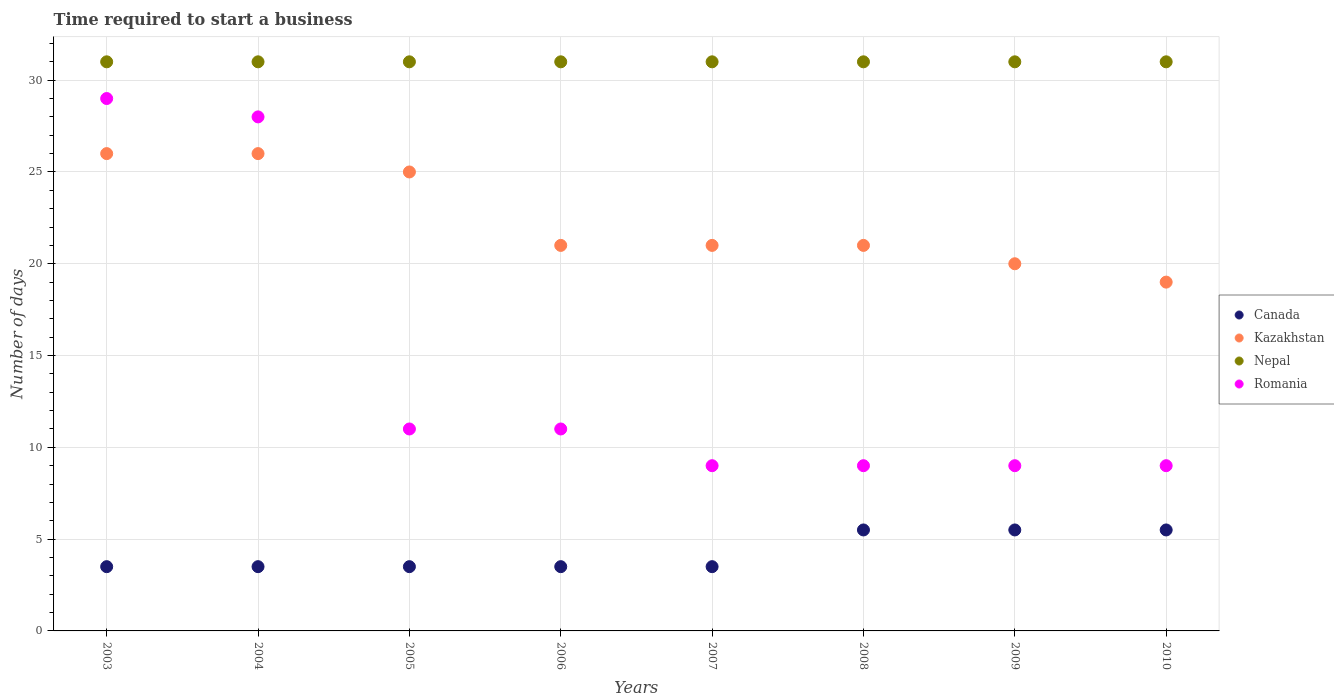Is the number of dotlines equal to the number of legend labels?
Make the answer very short. Yes. What is the number of days required to start a business in Kazakhstan in 2009?
Offer a terse response. 20. What is the total number of days required to start a business in Romania in the graph?
Keep it short and to the point. 115. What is the difference between the number of days required to start a business in Kazakhstan in 2003 and the number of days required to start a business in Romania in 2010?
Provide a short and direct response. 17. What is the average number of days required to start a business in Romania per year?
Your response must be concise. 14.38. What is the ratio of the number of days required to start a business in Kazakhstan in 2005 to that in 2008?
Your response must be concise. 1.19. What is the difference between the highest and the lowest number of days required to start a business in Kazakhstan?
Provide a short and direct response. 7. In how many years, is the number of days required to start a business in Kazakhstan greater than the average number of days required to start a business in Kazakhstan taken over all years?
Keep it short and to the point. 3. Is the sum of the number of days required to start a business in Nepal in 2003 and 2006 greater than the maximum number of days required to start a business in Kazakhstan across all years?
Ensure brevity in your answer.  Yes. Is the number of days required to start a business in Romania strictly greater than the number of days required to start a business in Kazakhstan over the years?
Keep it short and to the point. No. How many dotlines are there?
Your answer should be compact. 4. How many years are there in the graph?
Offer a very short reply. 8. Are the values on the major ticks of Y-axis written in scientific E-notation?
Provide a succinct answer. No. Does the graph contain any zero values?
Provide a short and direct response. No. Where does the legend appear in the graph?
Your answer should be compact. Center right. What is the title of the graph?
Give a very brief answer. Time required to start a business. What is the label or title of the X-axis?
Make the answer very short. Years. What is the label or title of the Y-axis?
Provide a succinct answer. Number of days. What is the Number of days in Kazakhstan in 2003?
Your answer should be compact. 26. What is the Number of days of Canada in 2004?
Offer a terse response. 3.5. What is the Number of days of Nepal in 2004?
Provide a succinct answer. 31. What is the Number of days in Canada in 2005?
Offer a very short reply. 3.5. What is the Number of days in Nepal in 2005?
Your answer should be very brief. 31. What is the Number of days in Romania in 2006?
Offer a very short reply. 11. What is the Number of days in Kazakhstan in 2007?
Your response must be concise. 21. What is the Number of days in Nepal in 2007?
Give a very brief answer. 31. What is the Number of days of Canada in 2008?
Your response must be concise. 5.5. What is the Number of days in Nepal in 2008?
Offer a very short reply. 31. What is the Number of days in Kazakhstan in 2009?
Provide a succinct answer. 20. What is the Number of days of Canada in 2010?
Ensure brevity in your answer.  5.5. What is the Number of days in Romania in 2010?
Offer a terse response. 9. Across all years, what is the maximum Number of days in Canada?
Offer a very short reply. 5.5. Across all years, what is the minimum Number of days of Canada?
Offer a terse response. 3.5. Across all years, what is the minimum Number of days in Romania?
Your answer should be compact. 9. What is the total Number of days of Kazakhstan in the graph?
Offer a terse response. 179. What is the total Number of days of Nepal in the graph?
Provide a succinct answer. 248. What is the total Number of days in Romania in the graph?
Your answer should be very brief. 115. What is the difference between the Number of days of Canada in 2003 and that in 2004?
Offer a terse response. 0. What is the difference between the Number of days in Kazakhstan in 2003 and that in 2004?
Keep it short and to the point. 0. What is the difference between the Number of days of Romania in 2003 and that in 2004?
Give a very brief answer. 1. What is the difference between the Number of days of Canada in 2003 and that in 2005?
Offer a terse response. 0. What is the difference between the Number of days in Canada in 2003 and that in 2006?
Your answer should be very brief. 0. What is the difference between the Number of days in Kazakhstan in 2003 and that in 2006?
Offer a terse response. 5. What is the difference between the Number of days of Romania in 2003 and that in 2006?
Keep it short and to the point. 18. What is the difference between the Number of days of Canada in 2003 and that in 2007?
Keep it short and to the point. 0. What is the difference between the Number of days in Kazakhstan in 2003 and that in 2007?
Provide a short and direct response. 5. What is the difference between the Number of days of Nepal in 2003 and that in 2007?
Keep it short and to the point. 0. What is the difference between the Number of days in Romania in 2003 and that in 2007?
Your answer should be very brief. 20. What is the difference between the Number of days of Canada in 2003 and that in 2008?
Your answer should be compact. -2. What is the difference between the Number of days in Nepal in 2003 and that in 2008?
Your answer should be compact. 0. What is the difference between the Number of days in Romania in 2003 and that in 2008?
Your answer should be very brief. 20. What is the difference between the Number of days of Canada in 2003 and that in 2009?
Offer a terse response. -2. What is the difference between the Number of days in Romania in 2003 and that in 2009?
Make the answer very short. 20. What is the difference between the Number of days of Canada in 2003 and that in 2010?
Your answer should be very brief. -2. What is the difference between the Number of days in Canada in 2004 and that in 2005?
Provide a succinct answer. 0. What is the difference between the Number of days in Kazakhstan in 2004 and that in 2005?
Offer a very short reply. 1. What is the difference between the Number of days of Nepal in 2004 and that in 2005?
Give a very brief answer. 0. What is the difference between the Number of days of Romania in 2004 and that in 2005?
Your response must be concise. 17. What is the difference between the Number of days of Romania in 2004 and that in 2006?
Keep it short and to the point. 17. What is the difference between the Number of days of Canada in 2004 and that in 2007?
Provide a succinct answer. 0. What is the difference between the Number of days of Kazakhstan in 2004 and that in 2007?
Your answer should be very brief. 5. What is the difference between the Number of days in Canada in 2004 and that in 2008?
Offer a very short reply. -2. What is the difference between the Number of days of Romania in 2004 and that in 2008?
Your response must be concise. 19. What is the difference between the Number of days in Canada in 2004 and that in 2009?
Offer a very short reply. -2. What is the difference between the Number of days in Nepal in 2004 and that in 2009?
Offer a very short reply. 0. What is the difference between the Number of days in Kazakhstan in 2004 and that in 2010?
Your response must be concise. 7. What is the difference between the Number of days in Canada in 2005 and that in 2006?
Keep it short and to the point. 0. What is the difference between the Number of days of Kazakhstan in 2005 and that in 2006?
Make the answer very short. 4. What is the difference between the Number of days in Nepal in 2005 and that in 2007?
Provide a short and direct response. 0. What is the difference between the Number of days in Nepal in 2005 and that in 2008?
Make the answer very short. 0. What is the difference between the Number of days of Romania in 2005 and that in 2008?
Your response must be concise. 2. What is the difference between the Number of days in Canada in 2005 and that in 2009?
Your response must be concise. -2. What is the difference between the Number of days of Nepal in 2005 and that in 2009?
Ensure brevity in your answer.  0. What is the difference between the Number of days of Romania in 2005 and that in 2009?
Provide a succinct answer. 2. What is the difference between the Number of days in Kazakhstan in 2006 and that in 2007?
Offer a terse response. 0. What is the difference between the Number of days of Romania in 2006 and that in 2007?
Give a very brief answer. 2. What is the difference between the Number of days in Canada in 2006 and that in 2008?
Your answer should be very brief. -2. What is the difference between the Number of days in Nepal in 2006 and that in 2008?
Provide a succinct answer. 0. What is the difference between the Number of days in Romania in 2006 and that in 2008?
Offer a terse response. 2. What is the difference between the Number of days in Canada in 2006 and that in 2009?
Your answer should be very brief. -2. What is the difference between the Number of days in Kazakhstan in 2006 and that in 2009?
Keep it short and to the point. 1. What is the difference between the Number of days in Nepal in 2006 and that in 2009?
Provide a short and direct response. 0. What is the difference between the Number of days in Canada in 2006 and that in 2010?
Keep it short and to the point. -2. What is the difference between the Number of days in Nepal in 2006 and that in 2010?
Ensure brevity in your answer.  0. What is the difference between the Number of days of Romania in 2006 and that in 2010?
Offer a very short reply. 2. What is the difference between the Number of days in Kazakhstan in 2007 and that in 2008?
Ensure brevity in your answer.  0. What is the difference between the Number of days in Nepal in 2007 and that in 2008?
Ensure brevity in your answer.  0. What is the difference between the Number of days of Kazakhstan in 2007 and that in 2009?
Offer a very short reply. 1. What is the difference between the Number of days of Nepal in 2007 and that in 2010?
Make the answer very short. 0. What is the difference between the Number of days in Kazakhstan in 2008 and that in 2009?
Your response must be concise. 1. What is the difference between the Number of days in Canada in 2008 and that in 2010?
Offer a very short reply. 0. What is the difference between the Number of days in Kazakhstan in 2008 and that in 2010?
Offer a very short reply. 2. What is the difference between the Number of days of Nepal in 2008 and that in 2010?
Make the answer very short. 0. What is the difference between the Number of days in Romania in 2008 and that in 2010?
Make the answer very short. 0. What is the difference between the Number of days in Nepal in 2009 and that in 2010?
Provide a succinct answer. 0. What is the difference between the Number of days of Canada in 2003 and the Number of days of Kazakhstan in 2004?
Give a very brief answer. -22.5. What is the difference between the Number of days in Canada in 2003 and the Number of days in Nepal in 2004?
Offer a terse response. -27.5. What is the difference between the Number of days in Canada in 2003 and the Number of days in Romania in 2004?
Offer a very short reply. -24.5. What is the difference between the Number of days in Kazakhstan in 2003 and the Number of days in Nepal in 2004?
Keep it short and to the point. -5. What is the difference between the Number of days of Nepal in 2003 and the Number of days of Romania in 2004?
Ensure brevity in your answer.  3. What is the difference between the Number of days in Canada in 2003 and the Number of days in Kazakhstan in 2005?
Ensure brevity in your answer.  -21.5. What is the difference between the Number of days in Canada in 2003 and the Number of days in Nepal in 2005?
Make the answer very short. -27.5. What is the difference between the Number of days of Nepal in 2003 and the Number of days of Romania in 2005?
Give a very brief answer. 20. What is the difference between the Number of days of Canada in 2003 and the Number of days of Kazakhstan in 2006?
Your answer should be very brief. -17.5. What is the difference between the Number of days of Canada in 2003 and the Number of days of Nepal in 2006?
Give a very brief answer. -27.5. What is the difference between the Number of days of Kazakhstan in 2003 and the Number of days of Romania in 2006?
Make the answer very short. 15. What is the difference between the Number of days of Nepal in 2003 and the Number of days of Romania in 2006?
Offer a very short reply. 20. What is the difference between the Number of days in Canada in 2003 and the Number of days in Kazakhstan in 2007?
Ensure brevity in your answer.  -17.5. What is the difference between the Number of days in Canada in 2003 and the Number of days in Nepal in 2007?
Provide a succinct answer. -27.5. What is the difference between the Number of days in Canada in 2003 and the Number of days in Romania in 2007?
Provide a short and direct response. -5.5. What is the difference between the Number of days of Canada in 2003 and the Number of days of Kazakhstan in 2008?
Keep it short and to the point. -17.5. What is the difference between the Number of days in Canada in 2003 and the Number of days in Nepal in 2008?
Your answer should be compact. -27.5. What is the difference between the Number of days in Kazakhstan in 2003 and the Number of days in Nepal in 2008?
Keep it short and to the point. -5. What is the difference between the Number of days in Nepal in 2003 and the Number of days in Romania in 2008?
Provide a short and direct response. 22. What is the difference between the Number of days of Canada in 2003 and the Number of days of Kazakhstan in 2009?
Provide a short and direct response. -16.5. What is the difference between the Number of days in Canada in 2003 and the Number of days in Nepal in 2009?
Ensure brevity in your answer.  -27.5. What is the difference between the Number of days in Kazakhstan in 2003 and the Number of days in Romania in 2009?
Provide a short and direct response. 17. What is the difference between the Number of days of Nepal in 2003 and the Number of days of Romania in 2009?
Your answer should be very brief. 22. What is the difference between the Number of days in Canada in 2003 and the Number of days in Kazakhstan in 2010?
Give a very brief answer. -15.5. What is the difference between the Number of days of Canada in 2003 and the Number of days of Nepal in 2010?
Provide a succinct answer. -27.5. What is the difference between the Number of days of Canada in 2003 and the Number of days of Romania in 2010?
Your response must be concise. -5.5. What is the difference between the Number of days in Kazakhstan in 2003 and the Number of days in Romania in 2010?
Your answer should be compact. 17. What is the difference between the Number of days of Canada in 2004 and the Number of days of Kazakhstan in 2005?
Ensure brevity in your answer.  -21.5. What is the difference between the Number of days of Canada in 2004 and the Number of days of Nepal in 2005?
Your answer should be very brief. -27.5. What is the difference between the Number of days in Canada in 2004 and the Number of days in Romania in 2005?
Your answer should be compact. -7.5. What is the difference between the Number of days in Nepal in 2004 and the Number of days in Romania in 2005?
Provide a short and direct response. 20. What is the difference between the Number of days in Canada in 2004 and the Number of days in Kazakhstan in 2006?
Your answer should be very brief. -17.5. What is the difference between the Number of days in Canada in 2004 and the Number of days in Nepal in 2006?
Offer a terse response. -27.5. What is the difference between the Number of days of Canada in 2004 and the Number of days of Romania in 2006?
Provide a succinct answer. -7.5. What is the difference between the Number of days of Kazakhstan in 2004 and the Number of days of Nepal in 2006?
Provide a short and direct response. -5. What is the difference between the Number of days of Kazakhstan in 2004 and the Number of days of Romania in 2006?
Give a very brief answer. 15. What is the difference between the Number of days of Nepal in 2004 and the Number of days of Romania in 2006?
Keep it short and to the point. 20. What is the difference between the Number of days of Canada in 2004 and the Number of days of Kazakhstan in 2007?
Offer a very short reply. -17.5. What is the difference between the Number of days in Canada in 2004 and the Number of days in Nepal in 2007?
Ensure brevity in your answer.  -27.5. What is the difference between the Number of days of Canada in 2004 and the Number of days of Romania in 2007?
Offer a terse response. -5.5. What is the difference between the Number of days of Kazakhstan in 2004 and the Number of days of Romania in 2007?
Provide a short and direct response. 17. What is the difference between the Number of days in Canada in 2004 and the Number of days in Kazakhstan in 2008?
Your answer should be compact. -17.5. What is the difference between the Number of days of Canada in 2004 and the Number of days of Nepal in 2008?
Your answer should be very brief. -27.5. What is the difference between the Number of days of Kazakhstan in 2004 and the Number of days of Nepal in 2008?
Your response must be concise. -5. What is the difference between the Number of days of Kazakhstan in 2004 and the Number of days of Romania in 2008?
Ensure brevity in your answer.  17. What is the difference between the Number of days in Nepal in 2004 and the Number of days in Romania in 2008?
Your answer should be very brief. 22. What is the difference between the Number of days of Canada in 2004 and the Number of days of Kazakhstan in 2009?
Provide a short and direct response. -16.5. What is the difference between the Number of days in Canada in 2004 and the Number of days in Nepal in 2009?
Offer a very short reply. -27.5. What is the difference between the Number of days in Kazakhstan in 2004 and the Number of days in Nepal in 2009?
Make the answer very short. -5. What is the difference between the Number of days in Canada in 2004 and the Number of days in Kazakhstan in 2010?
Make the answer very short. -15.5. What is the difference between the Number of days of Canada in 2004 and the Number of days of Nepal in 2010?
Keep it short and to the point. -27.5. What is the difference between the Number of days of Canada in 2004 and the Number of days of Romania in 2010?
Ensure brevity in your answer.  -5.5. What is the difference between the Number of days of Kazakhstan in 2004 and the Number of days of Nepal in 2010?
Ensure brevity in your answer.  -5. What is the difference between the Number of days in Nepal in 2004 and the Number of days in Romania in 2010?
Make the answer very short. 22. What is the difference between the Number of days in Canada in 2005 and the Number of days in Kazakhstan in 2006?
Your answer should be very brief. -17.5. What is the difference between the Number of days of Canada in 2005 and the Number of days of Nepal in 2006?
Give a very brief answer. -27.5. What is the difference between the Number of days of Canada in 2005 and the Number of days of Romania in 2006?
Ensure brevity in your answer.  -7.5. What is the difference between the Number of days in Nepal in 2005 and the Number of days in Romania in 2006?
Provide a succinct answer. 20. What is the difference between the Number of days in Canada in 2005 and the Number of days in Kazakhstan in 2007?
Make the answer very short. -17.5. What is the difference between the Number of days in Canada in 2005 and the Number of days in Nepal in 2007?
Your answer should be very brief. -27.5. What is the difference between the Number of days in Canada in 2005 and the Number of days in Romania in 2007?
Offer a very short reply. -5.5. What is the difference between the Number of days of Nepal in 2005 and the Number of days of Romania in 2007?
Provide a succinct answer. 22. What is the difference between the Number of days in Canada in 2005 and the Number of days in Kazakhstan in 2008?
Keep it short and to the point. -17.5. What is the difference between the Number of days of Canada in 2005 and the Number of days of Nepal in 2008?
Provide a succinct answer. -27.5. What is the difference between the Number of days of Canada in 2005 and the Number of days of Romania in 2008?
Offer a very short reply. -5.5. What is the difference between the Number of days in Nepal in 2005 and the Number of days in Romania in 2008?
Your answer should be compact. 22. What is the difference between the Number of days of Canada in 2005 and the Number of days of Kazakhstan in 2009?
Give a very brief answer. -16.5. What is the difference between the Number of days in Canada in 2005 and the Number of days in Nepal in 2009?
Your answer should be very brief. -27.5. What is the difference between the Number of days in Canada in 2005 and the Number of days in Romania in 2009?
Provide a short and direct response. -5.5. What is the difference between the Number of days of Kazakhstan in 2005 and the Number of days of Romania in 2009?
Make the answer very short. 16. What is the difference between the Number of days of Nepal in 2005 and the Number of days of Romania in 2009?
Ensure brevity in your answer.  22. What is the difference between the Number of days in Canada in 2005 and the Number of days in Kazakhstan in 2010?
Give a very brief answer. -15.5. What is the difference between the Number of days of Canada in 2005 and the Number of days of Nepal in 2010?
Ensure brevity in your answer.  -27.5. What is the difference between the Number of days in Nepal in 2005 and the Number of days in Romania in 2010?
Keep it short and to the point. 22. What is the difference between the Number of days of Canada in 2006 and the Number of days of Kazakhstan in 2007?
Give a very brief answer. -17.5. What is the difference between the Number of days in Canada in 2006 and the Number of days in Nepal in 2007?
Give a very brief answer. -27.5. What is the difference between the Number of days in Kazakhstan in 2006 and the Number of days in Nepal in 2007?
Offer a terse response. -10. What is the difference between the Number of days of Kazakhstan in 2006 and the Number of days of Romania in 2007?
Offer a very short reply. 12. What is the difference between the Number of days of Nepal in 2006 and the Number of days of Romania in 2007?
Keep it short and to the point. 22. What is the difference between the Number of days of Canada in 2006 and the Number of days of Kazakhstan in 2008?
Your answer should be compact. -17.5. What is the difference between the Number of days of Canada in 2006 and the Number of days of Nepal in 2008?
Make the answer very short. -27.5. What is the difference between the Number of days in Canada in 2006 and the Number of days in Romania in 2008?
Keep it short and to the point. -5.5. What is the difference between the Number of days of Nepal in 2006 and the Number of days of Romania in 2008?
Make the answer very short. 22. What is the difference between the Number of days in Canada in 2006 and the Number of days in Kazakhstan in 2009?
Give a very brief answer. -16.5. What is the difference between the Number of days of Canada in 2006 and the Number of days of Nepal in 2009?
Your response must be concise. -27.5. What is the difference between the Number of days of Kazakhstan in 2006 and the Number of days of Romania in 2009?
Keep it short and to the point. 12. What is the difference between the Number of days in Canada in 2006 and the Number of days in Kazakhstan in 2010?
Keep it short and to the point. -15.5. What is the difference between the Number of days in Canada in 2006 and the Number of days in Nepal in 2010?
Offer a very short reply. -27.5. What is the difference between the Number of days of Canada in 2007 and the Number of days of Kazakhstan in 2008?
Offer a terse response. -17.5. What is the difference between the Number of days of Canada in 2007 and the Number of days of Nepal in 2008?
Your answer should be compact. -27.5. What is the difference between the Number of days in Canada in 2007 and the Number of days in Romania in 2008?
Give a very brief answer. -5.5. What is the difference between the Number of days in Kazakhstan in 2007 and the Number of days in Nepal in 2008?
Ensure brevity in your answer.  -10. What is the difference between the Number of days of Canada in 2007 and the Number of days of Kazakhstan in 2009?
Make the answer very short. -16.5. What is the difference between the Number of days of Canada in 2007 and the Number of days of Nepal in 2009?
Ensure brevity in your answer.  -27.5. What is the difference between the Number of days of Canada in 2007 and the Number of days of Romania in 2009?
Your response must be concise. -5.5. What is the difference between the Number of days in Kazakhstan in 2007 and the Number of days in Nepal in 2009?
Provide a short and direct response. -10. What is the difference between the Number of days of Nepal in 2007 and the Number of days of Romania in 2009?
Your answer should be compact. 22. What is the difference between the Number of days of Canada in 2007 and the Number of days of Kazakhstan in 2010?
Offer a very short reply. -15.5. What is the difference between the Number of days in Canada in 2007 and the Number of days in Nepal in 2010?
Your answer should be very brief. -27.5. What is the difference between the Number of days in Kazakhstan in 2007 and the Number of days in Romania in 2010?
Keep it short and to the point. 12. What is the difference between the Number of days of Nepal in 2007 and the Number of days of Romania in 2010?
Your response must be concise. 22. What is the difference between the Number of days of Canada in 2008 and the Number of days of Nepal in 2009?
Give a very brief answer. -25.5. What is the difference between the Number of days in Canada in 2008 and the Number of days in Romania in 2009?
Give a very brief answer. -3.5. What is the difference between the Number of days of Kazakhstan in 2008 and the Number of days of Nepal in 2009?
Your response must be concise. -10. What is the difference between the Number of days of Kazakhstan in 2008 and the Number of days of Romania in 2009?
Keep it short and to the point. 12. What is the difference between the Number of days in Canada in 2008 and the Number of days in Nepal in 2010?
Ensure brevity in your answer.  -25.5. What is the difference between the Number of days of Canada in 2008 and the Number of days of Romania in 2010?
Give a very brief answer. -3.5. What is the difference between the Number of days of Nepal in 2008 and the Number of days of Romania in 2010?
Give a very brief answer. 22. What is the difference between the Number of days in Canada in 2009 and the Number of days in Kazakhstan in 2010?
Provide a short and direct response. -13.5. What is the difference between the Number of days in Canada in 2009 and the Number of days in Nepal in 2010?
Keep it short and to the point. -25.5. What is the difference between the Number of days of Kazakhstan in 2009 and the Number of days of Nepal in 2010?
Make the answer very short. -11. What is the difference between the Number of days in Nepal in 2009 and the Number of days in Romania in 2010?
Offer a very short reply. 22. What is the average Number of days of Canada per year?
Provide a succinct answer. 4.25. What is the average Number of days in Kazakhstan per year?
Your response must be concise. 22.38. What is the average Number of days in Romania per year?
Give a very brief answer. 14.38. In the year 2003, what is the difference between the Number of days in Canada and Number of days in Kazakhstan?
Your answer should be compact. -22.5. In the year 2003, what is the difference between the Number of days of Canada and Number of days of Nepal?
Give a very brief answer. -27.5. In the year 2003, what is the difference between the Number of days of Canada and Number of days of Romania?
Provide a short and direct response. -25.5. In the year 2004, what is the difference between the Number of days in Canada and Number of days in Kazakhstan?
Offer a terse response. -22.5. In the year 2004, what is the difference between the Number of days in Canada and Number of days in Nepal?
Provide a short and direct response. -27.5. In the year 2004, what is the difference between the Number of days in Canada and Number of days in Romania?
Provide a short and direct response. -24.5. In the year 2004, what is the difference between the Number of days in Nepal and Number of days in Romania?
Give a very brief answer. 3. In the year 2005, what is the difference between the Number of days in Canada and Number of days in Kazakhstan?
Your answer should be very brief. -21.5. In the year 2005, what is the difference between the Number of days in Canada and Number of days in Nepal?
Give a very brief answer. -27.5. In the year 2005, what is the difference between the Number of days of Canada and Number of days of Romania?
Provide a succinct answer. -7.5. In the year 2005, what is the difference between the Number of days in Kazakhstan and Number of days in Nepal?
Keep it short and to the point. -6. In the year 2005, what is the difference between the Number of days of Nepal and Number of days of Romania?
Ensure brevity in your answer.  20. In the year 2006, what is the difference between the Number of days in Canada and Number of days in Kazakhstan?
Ensure brevity in your answer.  -17.5. In the year 2006, what is the difference between the Number of days in Canada and Number of days in Nepal?
Ensure brevity in your answer.  -27.5. In the year 2006, what is the difference between the Number of days of Kazakhstan and Number of days of Nepal?
Offer a terse response. -10. In the year 2006, what is the difference between the Number of days of Kazakhstan and Number of days of Romania?
Provide a succinct answer. 10. In the year 2006, what is the difference between the Number of days in Nepal and Number of days in Romania?
Your answer should be very brief. 20. In the year 2007, what is the difference between the Number of days in Canada and Number of days in Kazakhstan?
Keep it short and to the point. -17.5. In the year 2007, what is the difference between the Number of days of Canada and Number of days of Nepal?
Keep it short and to the point. -27.5. In the year 2007, what is the difference between the Number of days in Canada and Number of days in Romania?
Keep it short and to the point. -5.5. In the year 2007, what is the difference between the Number of days in Kazakhstan and Number of days in Nepal?
Make the answer very short. -10. In the year 2007, what is the difference between the Number of days in Nepal and Number of days in Romania?
Your response must be concise. 22. In the year 2008, what is the difference between the Number of days in Canada and Number of days in Kazakhstan?
Ensure brevity in your answer.  -15.5. In the year 2008, what is the difference between the Number of days of Canada and Number of days of Nepal?
Keep it short and to the point. -25.5. In the year 2009, what is the difference between the Number of days in Canada and Number of days in Kazakhstan?
Ensure brevity in your answer.  -14.5. In the year 2009, what is the difference between the Number of days of Canada and Number of days of Nepal?
Offer a terse response. -25.5. In the year 2009, what is the difference between the Number of days in Canada and Number of days in Romania?
Your answer should be very brief. -3.5. In the year 2009, what is the difference between the Number of days of Kazakhstan and Number of days of Nepal?
Provide a succinct answer. -11. In the year 2009, what is the difference between the Number of days in Kazakhstan and Number of days in Romania?
Your response must be concise. 11. In the year 2009, what is the difference between the Number of days of Nepal and Number of days of Romania?
Your response must be concise. 22. In the year 2010, what is the difference between the Number of days of Canada and Number of days of Kazakhstan?
Your answer should be compact. -13.5. In the year 2010, what is the difference between the Number of days in Canada and Number of days in Nepal?
Keep it short and to the point. -25.5. In the year 2010, what is the difference between the Number of days of Canada and Number of days of Romania?
Keep it short and to the point. -3.5. In the year 2010, what is the difference between the Number of days in Kazakhstan and Number of days in Nepal?
Your answer should be compact. -12. In the year 2010, what is the difference between the Number of days in Kazakhstan and Number of days in Romania?
Give a very brief answer. 10. What is the ratio of the Number of days in Canada in 2003 to that in 2004?
Provide a succinct answer. 1. What is the ratio of the Number of days of Kazakhstan in 2003 to that in 2004?
Provide a succinct answer. 1. What is the ratio of the Number of days in Nepal in 2003 to that in 2004?
Provide a short and direct response. 1. What is the ratio of the Number of days in Romania in 2003 to that in 2004?
Offer a very short reply. 1.04. What is the ratio of the Number of days of Kazakhstan in 2003 to that in 2005?
Your response must be concise. 1.04. What is the ratio of the Number of days of Romania in 2003 to that in 2005?
Keep it short and to the point. 2.64. What is the ratio of the Number of days in Kazakhstan in 2003 to that in 2006?
Offer a very short reply. 1.24. What is the ratio of the Number of days in Romania in 2003 to that in 2006?
Your response must be concise. 2.64. What is the ratio of the Number of days in Canada in 2003 to that in 2007?
Give a very brief answer. 1. What is the ratio of the Number of days of Kazakhstan in 2003 to that in 2007?
Ensure brevity in your answer.  1.24. What is the ratio of the Number of days of Nepal in 2003 to that in 2007?
Your answer should be very brief. 1. What is the ratio of the Number of days in Romania in 2003 to that in 2007?
Ensure brevity in your answer.  3.22. What is the ratio of the Number of days of Canada in 2003 to that in 2008?
Keep it short and to the point. 0.64. What is the ratio of the Number of days of Kazakhstan in 2003 to that in 2008?
Your answer should be compact. 1.24. What is the ratio of the Number of days in Nepal in 2003 to that in 2008?
Your answer should be compact. 1. What is the ratio of the Number of days in Romania in 2003 to that in 2008?
Give a very brief answer. 3.22. What is the ratio of the Number of days in Canada in 2003 to that in 2009?
Ensure brevity in your answer.  0.64. What is the ratio of the Number of days of Nepal in 2003 to that in 2009?
Provide a short and direct response. 1. What is the ratio of the Number of days of Romania in 2003 to that in 2009?
Offer a terse response. 3.22. What is the ratio of the Number of days in Canada in 2003 to that in 2010?
Offer a terse response. 0.64. What is the ratio of the Number of days of Kazakhstan in 2003 to that in 2010?
Provide a succinct answer. 1.37. What is the ratio of the Number of days in Nepal in 2003 to that in 2010?
Your answer should be compact. 1. What is the ratio of the Number of days of Romania in 2003 to that in 2010?
Keep it short and to the point. 3.22. What is the ratio of the Number of days in Canada in 2004 to that in 2005?
Provide a short and direct response. 1. What is the ratio of the Number of days in Nepal in 2004 to that in 2005?
Your response must be concise. 1. What is the ratio of the Number of days in Romania in 2004 to that in 2005?
Keep it short and to the point. 2.55. What is the ratio of the Number of days of Canada in 2004 to that in 2006?
Your answer should be very brief. 1. What is the ratio of the Number of days of Kazakhstan in 2004 to that in 2006?
Your answer should be compact. 1.24. What is the ratio of the Number of days of Nepal in 2004 to that in 2006?
Your response must be concise. 1. What is the ratio of the Number of days of Romania in 2004 to that in 2006?
Provide a succinct answer. 2.55. What is the ratio of the Number of days of Kazakhstan in 2004 to that in 2007?
Provide a short and direct response. 1.24. What is the ratio of the Number of days in Romania in 2004 to that in 2007?
Provide a succinct answer. 3.11. What is the ratio of the Number of days in Canada in 2004 to that in 2008?
Provide a succinct answer. 0.64. What is the ratio of the Number of days of Kazakhstan in 2004 to that in 2008?
Your response must be concise. 1.24. What is the ratio of the Number of days in Nepal in 2004 to that in 2008?
Make the answer very short. 1. What is the ratio of the Number of days in Romania in 2004 to that in 2008?
Offer a very short reply. 3.11. What is the ratio of the Number of days of Canada in 2004 to that in 2009?
Provide a short and direct response. 0.64. What is the ratio of the Number of days of Romania in 2004 to that in 2009?
Provide a short and direct response. 3.11. What is the ratio of the Number of days of Canada in 2004 to that in 2010?
Offer a very short reply. 0.64. What is the ratio of the Number of days of Kazakhstan in 2004 to that in 2010?
Give a very brief answer. 1.37. What is the ratio of the Number of days in Nepal in 2004 to that in 2010?
Offer a very short reply. 1. What is the ratio of the Number of days in Romania in 2004 to that in 2010?
Your answer should be very brief. 3.11. What is the ratio of the Number of days in Kazakhstan in 2005 to that in 2006?
Provide a succinct answer. 1.19. What is the ratio of the Number of days in Nepal in 2005 to that in 2006?
Provide a short and direct response. 1. What is the ratio of the Number of days in Canada in 2005 to that in 2007?
Offer a terse response. 1. What is the ratio of the Number of days in Kazakhstan in 2005 to that in 2007?
Your answer should be very brief. 1.19. What is the ratio of the Number of days in Romania in 2005 to that in 2007?
Provide a succinct answer. 1.22. What is the ratio of the Number of days of Canada in 2005 to that in 2008?
Your answer should be compact. 0.64. What is the ratio of the Number of days of Kazakhstan in 2005 to that in 2008?
Give a very brief answer. 1.19. What is the ratio of the Number of days of Nepal in 2005 to that in 2008?
Give a very brief answer. 1. What is the ratio of the Number of days in Romania in 2005 to that in 2008?
Ensure brevity in your answer.  1.22. What is the ratio of the Number of days of Canada in 2005 to that in 2009?
Give a very brief answer. 0.64. What is the ratio of the Number of days of Nepal in 2005 to that in 2009?
Offer a very short reply. 1. What is the ratio of the Number of days of Romania in 2005 to that in 2009?
Provide a succinct answer. 1.22. What is the ratio of the Number of days of Canada in 2005 to that in 2010?
Your response must be concise. 0.64. What is the ratio of the Number of days of Kazakhstan in 2005 to that in 2010?
Keep it short and to the point. 1.32. What is the ratio of the Number of days of Nepal in 2005 to that in 2010?
Offer a very short reply. 1. What is the ratio of the Number of days in Romania in 2005 to that in 2010?
Provide a short and direct response. 1.22. What is the ratio of the Number of days of Nepal in 2006 to that in 2007?
Make the answer very short. 1. What is the ratio of the Number of days in Romania in 2006 to that in 2007?
Offer a very short reply. 1.22. What is the ratio of the Number of days in Canada in 2006 to that in 2008?
Ensure brevity in your answer.  0.64. What is the ratio of the Number of days in Nepal in 2006 to that in 2008?
Your answer should be very brief. 1. What is the ratio of the Number of days in Romania in 2006 to that in 2008?
Keep it short and to the point. 1.22. What is the ratio of the Number of days of Canada in 2006 to that in 2009?
Offer a terse response. 0.64. What is the ratio of the Number of days in Kazakhstan in 2006 to that in 2009?
Offer a terse response. 1.05. What is the ratio of the Number of days in Romania in 2006 to that in 2009?
Ensure brevity in your answer.  1.22. What is the ratio of the Number of days of Canada in 2006 to that in 2010?
Ensure brevity in your answer.  0.64. What is the ratio of the Number of days of Kazakhstan in 2006 to that in 2010?
Your answer should be very brief. 1.11. What is the ratio of the Number of days of Romania in 2006 to that in 2010?
Provide a succinct answer. 1.22. What is the ratio of the Number of days of Canada in 2007 to that in 2008?
Provide a short and direct response. 0.64. What is the ratio of the Number of days in Kazakhstan in 2007 to that in 2008?
Provide a succinct answer. 1. What is the ratio of the Number of days in Canada in 2007 to that in 2009?
Your answer should be very brief. 0.64. What is the ratio of the Number of days in Romania in 2007 to that in 2009?
Provide a succinct answer. 1. What is the ratio of the Number of days in Canada in 2007 to that in 2010?
Give a very brief answer. 0.64. What is the ratio of the Number of days of Kazakhstan in 2007 to that in 2010?
Give a very brief answer. 1.11. What is the ratio of the Number of days in Canada in 2008 to that in 2009?
Offer a very short reply. 1. What is the ratio of the Number of days in Canada in 2008 to that in 2010?
Your response must be concise. 1. What is the ratio of the Number of days of Kazakhstan in 2008 to that in 2010?
Ensure brevity in your answer.  1.11. What is the ratio of the Number of days of Nepal in 2008 to that in 2010?
Offer a terse response. 1. What is the ratio of the Number of days of Romania in 2008 to that in 2010?
Your answer should be very brief. 1. What is the ratio of the Number of days of Kazakhstan in 2009 to that in 2010?
Ensure brevity in your answer.  1.05. What is the ratio of the Number of days in Romania in 2009 to that in 2010?
Your response must be concise. 1. What is the difference between the highest and the second highest Number of days of Romania?
Your answer should be compact. 1. What is the difference between the highest and the lowest Number of days in Kazakhstan?
Ensure brevity in your answer.  7. What is the difference between the highest and the lowest Number of days in Nepal?
Offer a very short reply. 0. 